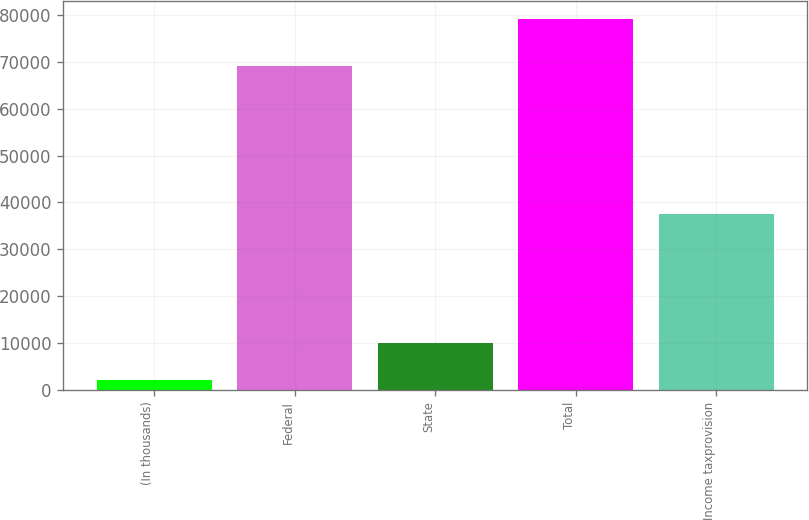Convert chart to OTSL. <chart><loc_0><loc_0><loc_500><loc_500><bar_chart><fcel>(In thousands)<fcel>Federal<fcel>State<fcel>Total<fcel>Income taxprovision<nl><fcel>2009<fcel>69095<fcel>9992<fcel>79087<fcel>37585<nl></chart> 